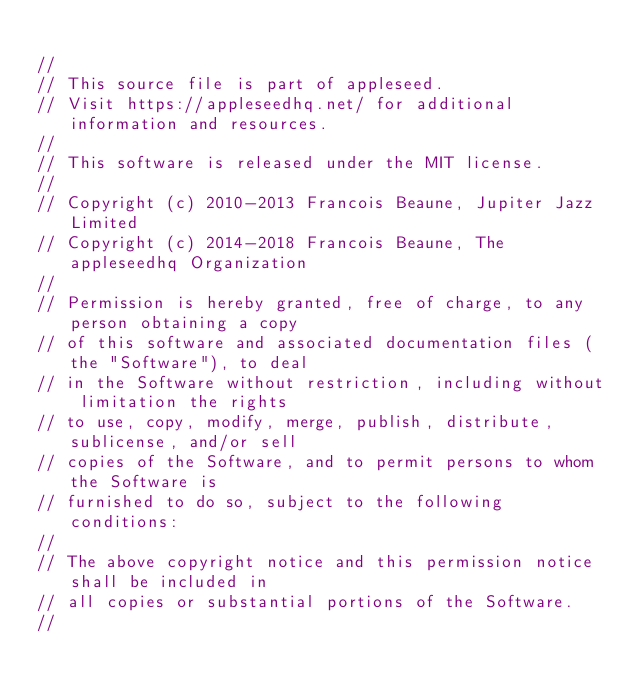Convert code to text. <code><loc_0><loc_0><loc_500><loc_500><_C_>
//
// This source file is part of appleseed.
// Visit https://appleseedhq.net/ for additional information and resources.
//
// This software is released under the MIT license.
//
// Copyright (c) 2010-2013 Francois Beaune, Jupiter Jazz Limited
// Copyright (c) 2014-2018 Francois Beaune, The appleseedhq Organization
//
// Permission is hereby granted, free of charge, to any person obtaining a copy
// of this software and associated documentation files (the "Software"), to deal
// in the Software without restriction, including without limitation the rights
// to use, copy, modify, merge, publish, distribute, sublicense, and/or sell
// copies of the Software, and to permit persons to whom the Software is
// furnished to do so, subject to the following conditions:
//
// The above copyright notice and this permission notice shall be included in
// all copies or substantial portions of the Software.
//</code> 